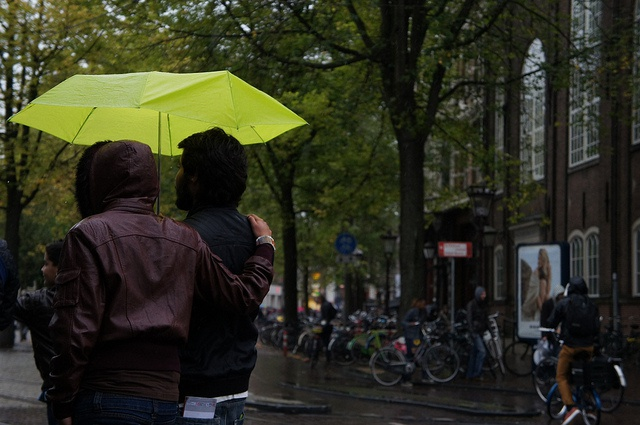Describe the objects in this image and their specific colors. I can see people in gray and black tones, umbrella in gray and khaki tones, people in gray, black, olive, maroon, and darkgreen tones, people in gray, black, maroon, and darkgray tones, and people in gray and black tones in this image. 